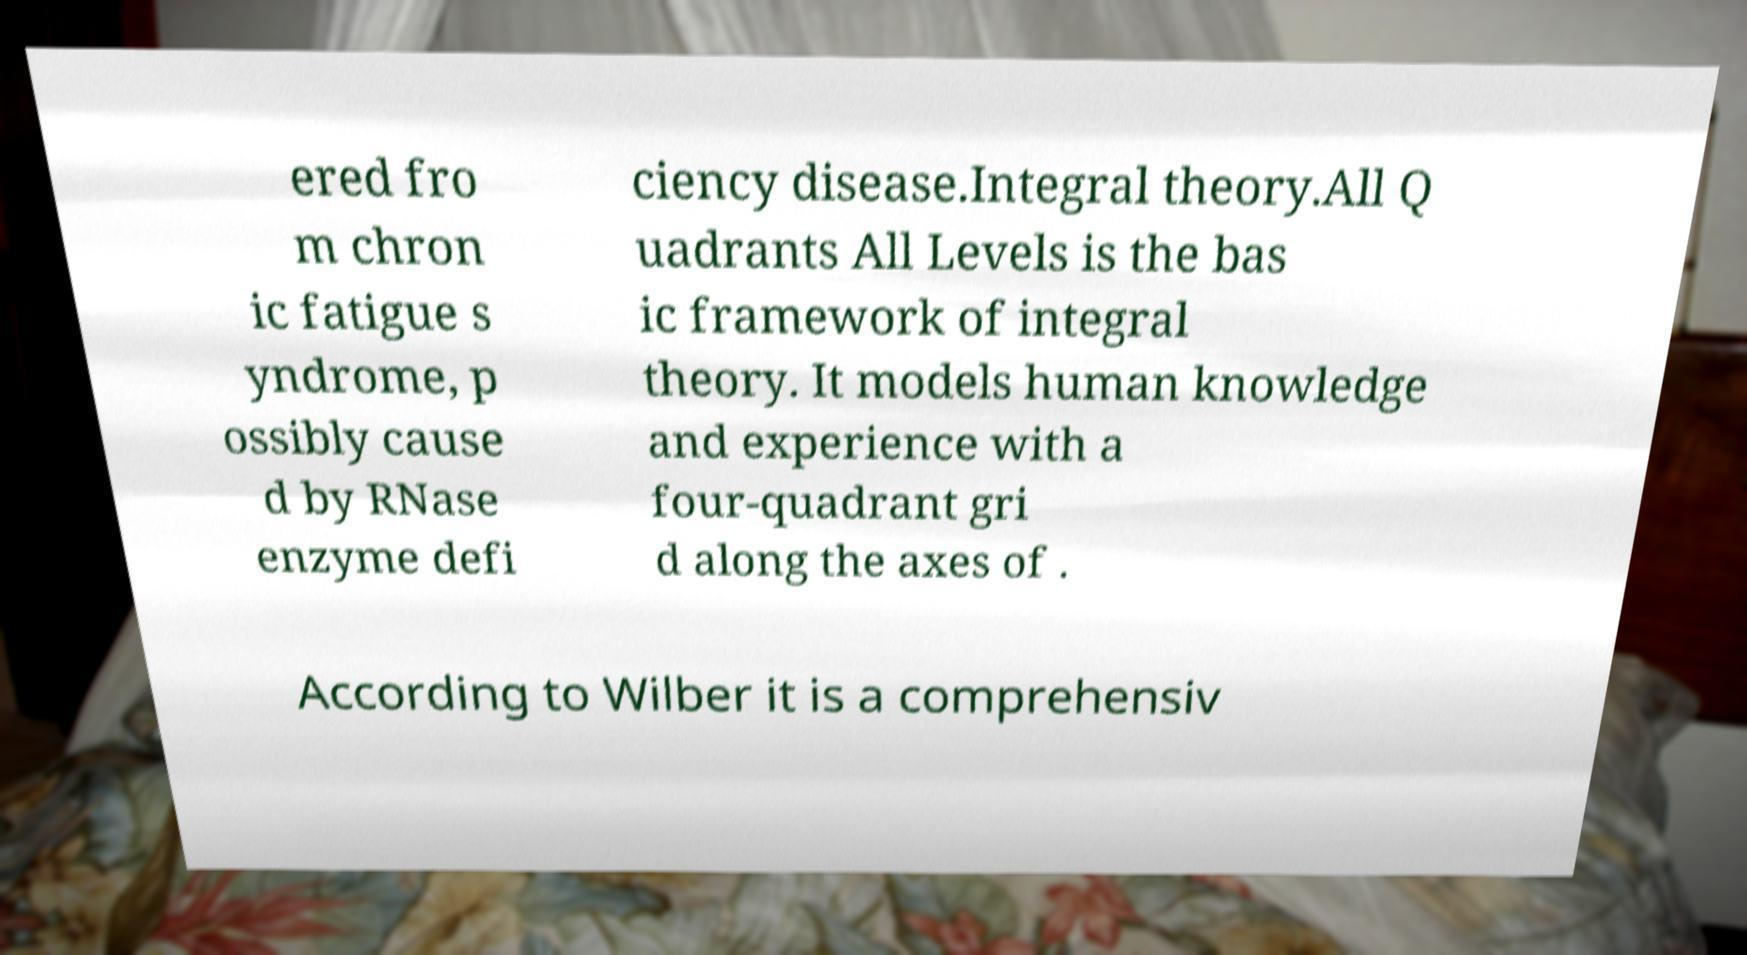For documentation purposes, I need the text within this image transcribed. Could you provide that? ered fro m chron ic fatigue s yndrome, p ossibly cause d by RNase enzyme defi ciency disease.Integral theory.All Q uadrants All Levels is the bas ic framework of integral theory. It models human knowledge and experience with a four-quadrant gri d along the axes of . According to Wilber it is a comprehensiv 